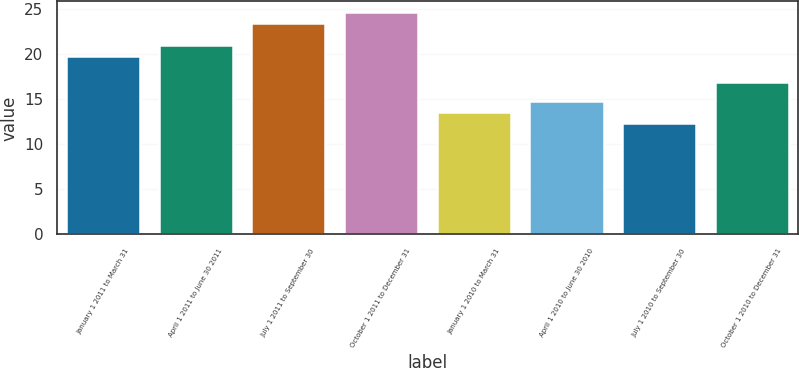<chart> <loc_0><loc_0><loc_500><loc_500><bar_chart><fcel>January 1 2011 to March 31<fcel>April 1 2011 to June 30 2011<fcel>July 1 2011 to September 30<fcel>October 1 2011 to December 31<fcel>January 1 2010 to March 31<fcel>April 1 2010 to June 30 2010<fcel>July 1 2010 to September 30<fcel>October 1 2010 to December 31<nl><fcel>19.78<fcel>21<fcel>23.41<fcel>24.63<fcel>13.61<fcel>14.83<fcel>12.39<fcel>16.93<nl></chart> 